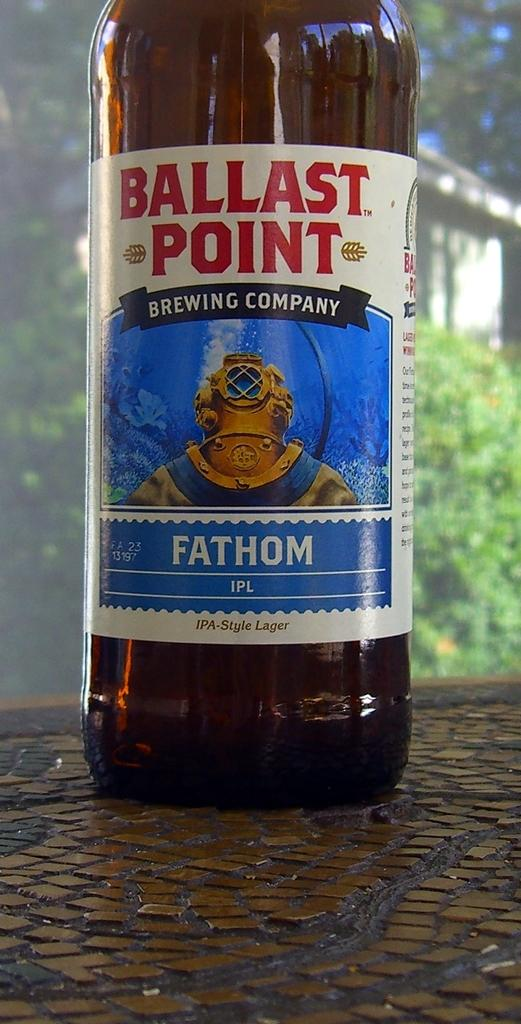<image>
Write a terse but informative summary of the picture. A botle of Ballast Point beer rests on a table outside. 